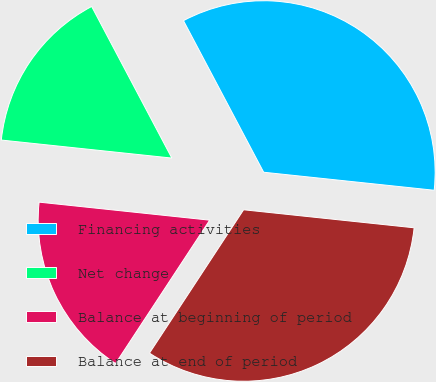Convert chart to OTSL. <chart><loc_0><loc_0><loc_500><loc_500><pie_chart><fcel>Financing activities<fcel>Net change<fcel>Balance at beginning of period<fcel>Balance at end of period<nl><fcel>34.42%<fcel>15.58%<fcel>17.43%<fcel>32.57%<nl></chart> 